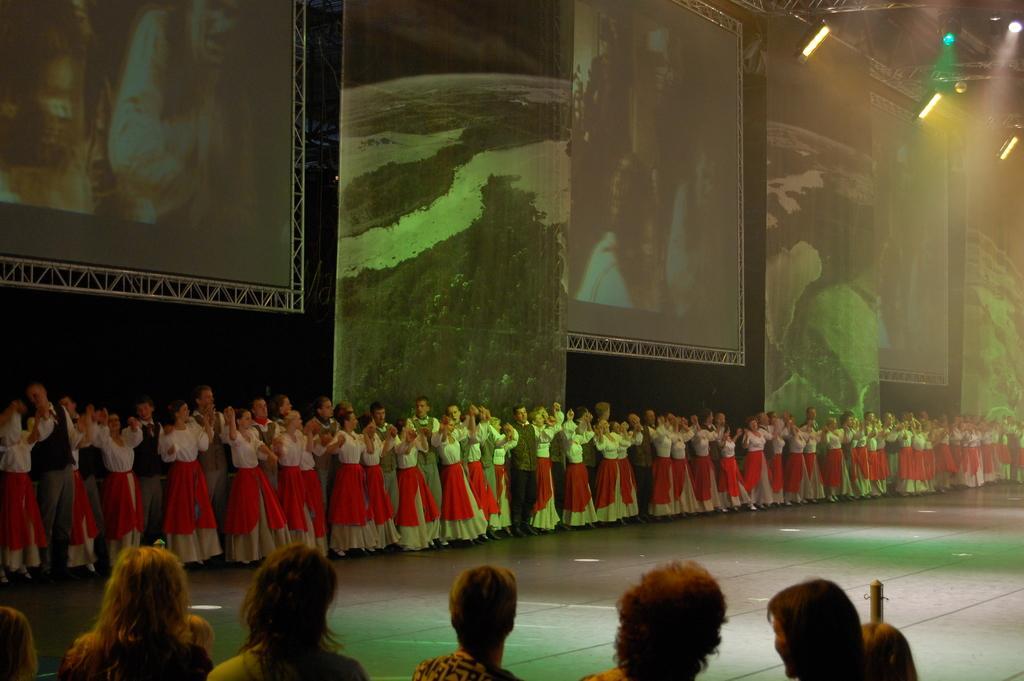Could you give a brief overview of what you see in this image? In the image I can see there are so many people in same costume are standing on the stage behind them there are some paintings on the wall also there are some other people in-front of the stage. 